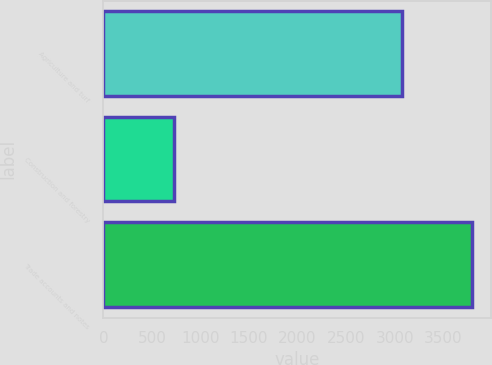Convert chart. <chart><loc_0><loc_0><loc_500><loc_500><bar_chart><fcel>Agriculture and turf<fcel>Construction and forestry<fcel>Trade accounts and notes<nl><fcel>3074<fcel>725<fcel>3799<nl></chart> 